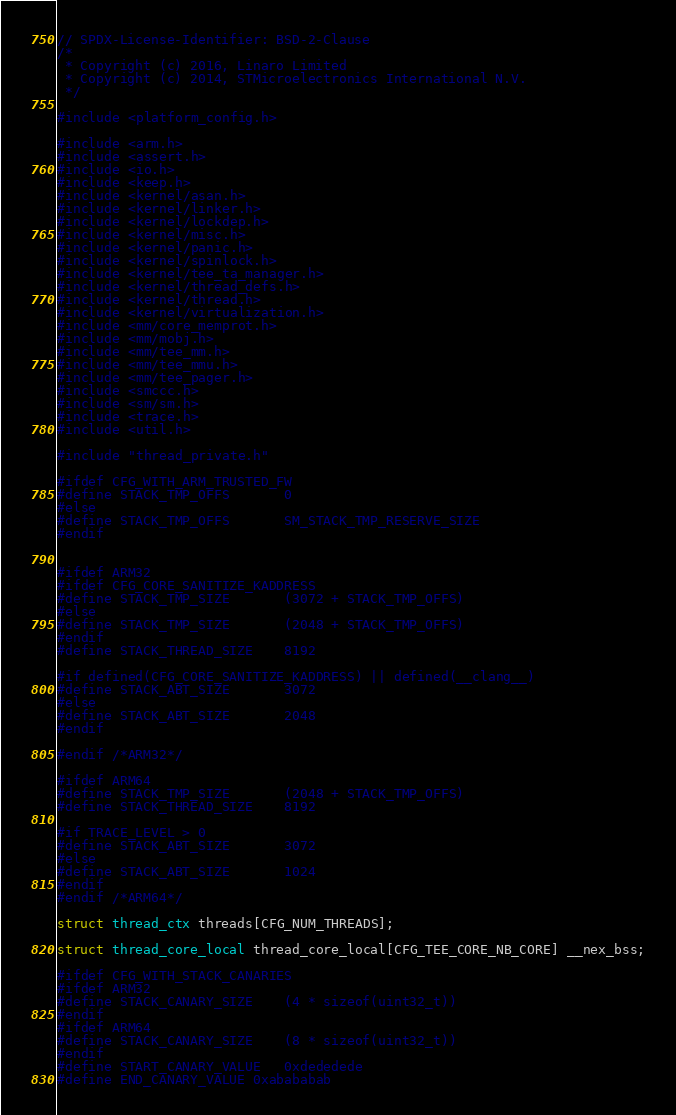<code> <loc_0><loc_0><loc_500><loc_500><_C_>// SPDX-License-Identifier: BSD-2-Clause
/*
 * Copyright (c) 2016, Linaro Limited
 * Copyright (c) 2014, STMicroelectronics International N.V.
 */

#include <platform_config.h>

#include <arm.h>
#include <assert.h>
#include <io.h>
#include <keep.h>
#include <kernel/asan.h>
#include <kernel/linker.h>
#include <kernel/lockdep.h>
#include <kernel/misc.h>
#include <kernel/panic.h>
#include <kernel/spinlock.h>
#include <kernel/tee_ta_manager.h>
#include <kernel/thread_defs.h>
#include <kernel/thread.h>
#include <kernel/virtualization.h>
#include <mm/core_memprot.h>
#include <mm/mobj.h>
#include <mm/tee_mm.h>
#include <mm/tee_mmu.h>
#include <mm/tee_pager.h>
#include <smccc.h>
#include <sm/sm.h>
#include <trace.h>
#include <util.h>

#include "thread_private.h"

#ifdef CFG_WITH_ARM_TRUSTED_FW
#define STACK_TMP_OFFS		0
#else
#define STACK_TMP_OFFS		SM_STACK_TMP_RESERVE_SIZE
#endif


#ifdef ARM32
#ifdef CFG_CORE_SANITIZE_KADDRESS
#define STACK_TMP_SIZE		(3072 + STACK_TMP_OFFS)
#else
#define STACK_TMP_SIZE		(2048 + STACK_TMP_OFFS)
#endif
#define STACK_THREAD_SIZE	8192

#if defined(CFG_CORE_SANITIZE_KADDRESS) || defined(__clang__)
#define STACK_ABT_SIZE		3072
#else
#define STACK_ABT_SIZE		2048
#endif

#endif /*ARM32*/

#ifdef ARM64
#define STACK_TMP_SIZE		(2048 + STACK_TMP_OFFS)
#define STACK_THREAD_SIZE	8192

#if TRACE_LEVEL > 0
#define STACK_ABT_SIZE		3072
#else
#define STACK_ABT_SIZE		1024
#endif
#endif /*ARM64*/

struct thread_ctx threads[CFG_NUM_THREADS];

struct thread_core_local thread_core_local[CFG_TEE_CORE_NB_CORE] __nex_bss;

#ifdef CFG_WITH_STACK_CANARIES
#ifdef ARM32
#define STACK_CANARY_SIZE	(4 * sizeof(uint32_t))
#endif
#ifdef ARM64
#define STACK_CANARY_SIZE	(8 * sizeof(uint32_t))
#endif
#define START_CANARY_VALUE	0xdededede
#define END_CANARY_VALUE	0xabababab</code> 